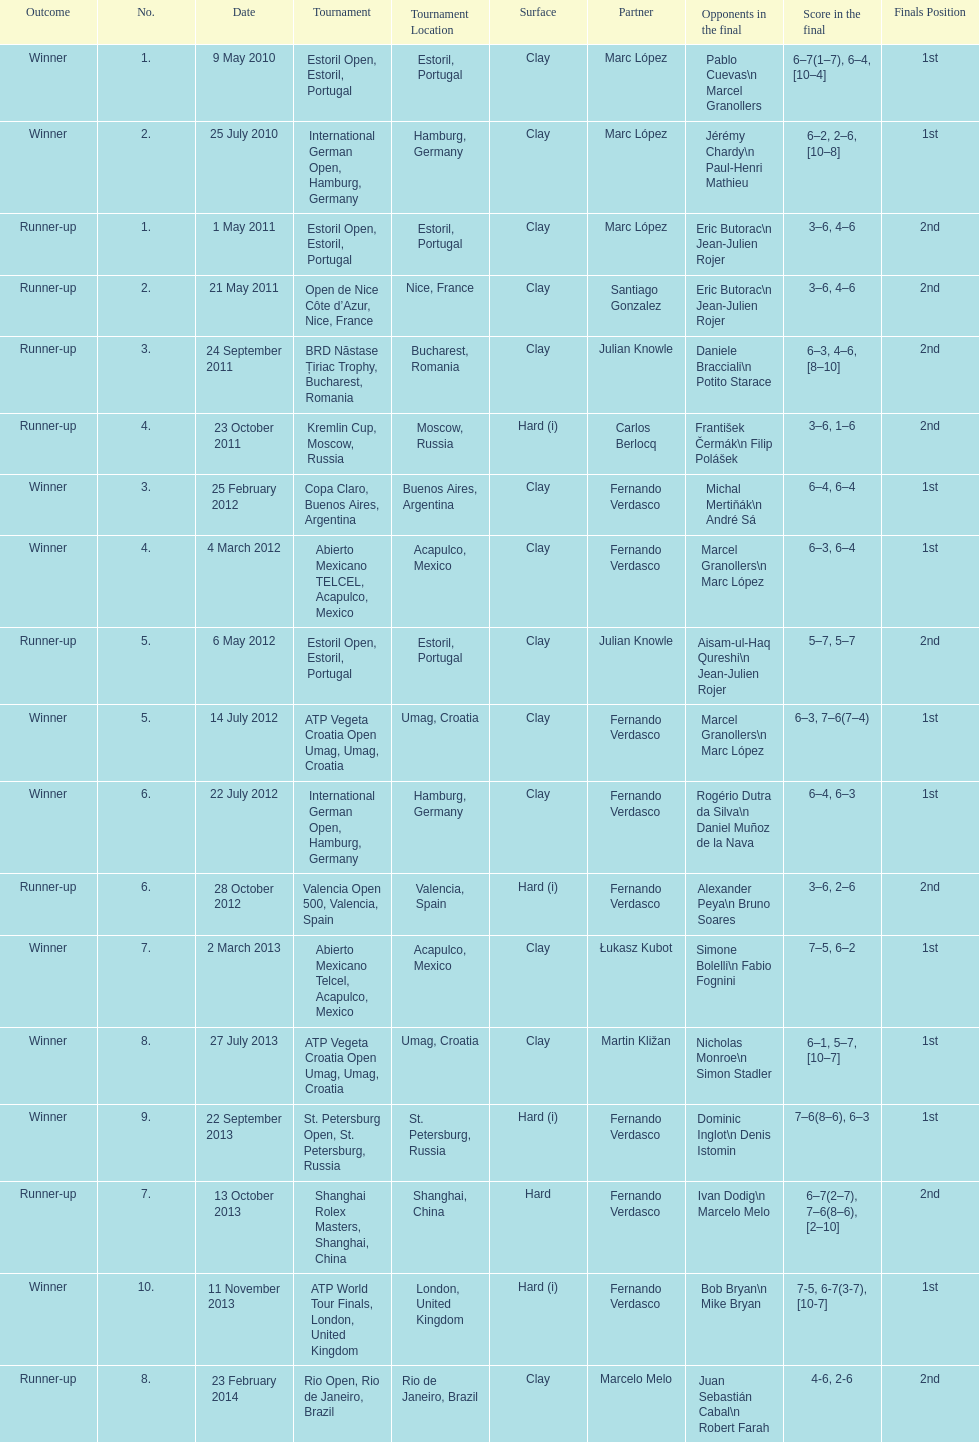What is the number of winning outcomes? 10. 